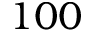<formula> <loc_0><loc_0><loc_500><loc_500>1 0 0</formula> 